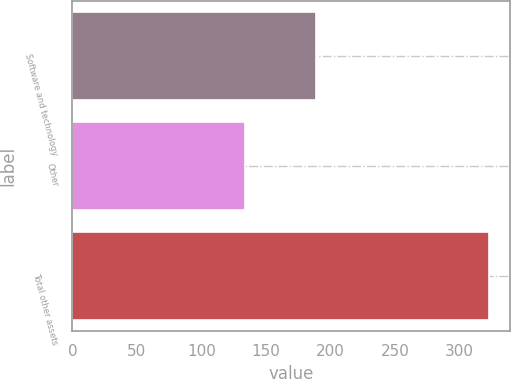Convert chart. <chart><loc_0><loc_0><loc_500><loc_500><bar_chart><fcel>Software and technology<fcel>Other<fcel>Total other assets<nl><fcel>189<fcel>134<fcel>323<nl></chart> 